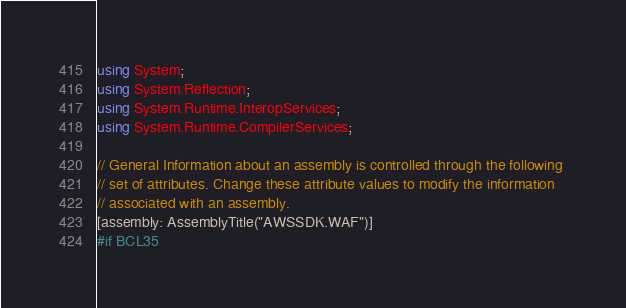<code> <loc_0><loc_0><loc_500><loc_500><_C#_>using System;
using System.Reflection;
using System.Runtime.InteropServices;
using System.Runtime.CompilerServices;

// General Information about an assembly is controlled through the following 
// set of attributes. Change these attribute values to modify the information
// associated with an assembly.
[assembly: AssemblyTitle("AWSSDK.WAF")]
#if BCL35</code> 